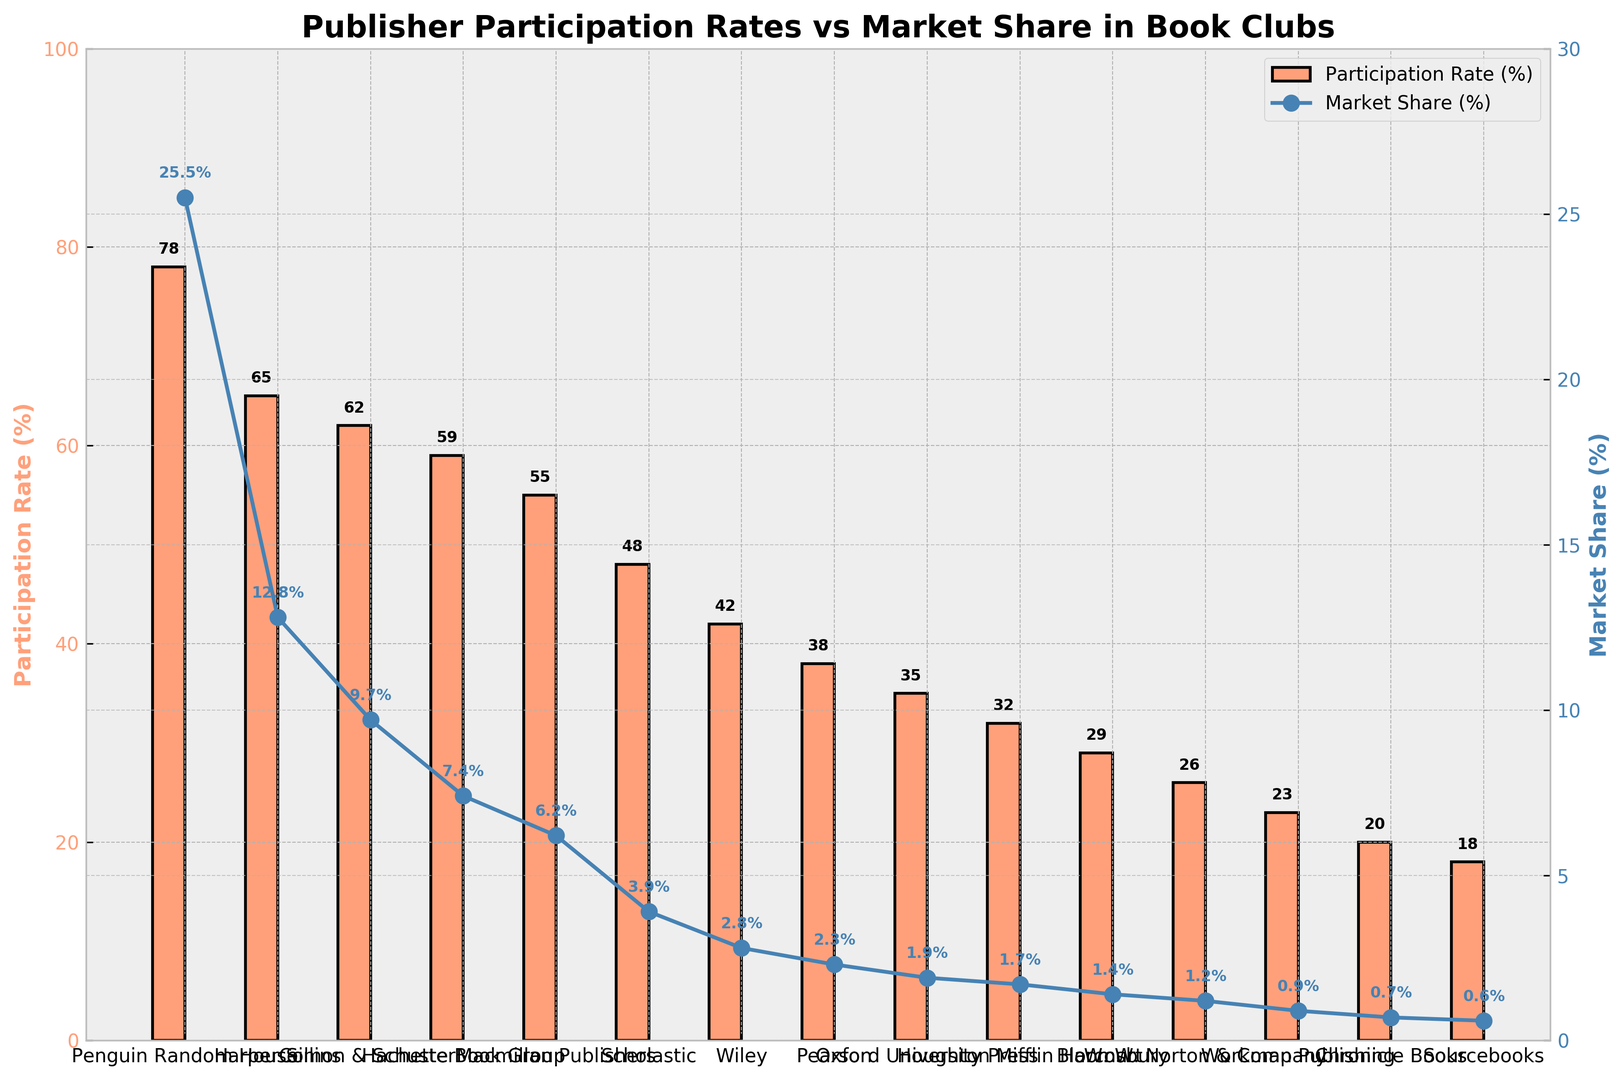What's the participation rate of HarperCollins? To find the participation rate of HarperCollins, look at the height of the corresponding red bar on the chart labelled HarperCollins, which shows participation rates on the y-axis.
Answer: 65% How does Pearson's participation rate compare to Oxford University Press's participation rate? Find the red bars for Pearson and Oxford University Press. Measure the heights of each bar to see the participation rates, which are 38% for Pearson and 35% for Oxford University Press. Comparing these, Pearson's participation rate is higher by 3%.
Answer: Pearson's participation rate is 3% higher than Oxford University Press's Which publisher has the largest market share, and what is it? The largest market share is represented by the highest blue dot on the second y-axis. Identifying the highest blue dot, it belongs to Penguin Random House with a market share of 25.5%.
Answer: Penguin Random House, 25.5% What's the total participation rate of Penguin Random House and HarperCollins combined? The participation rate of Penguin Random House is 78%, and HarperCollins is 65%. Add these two values together to get the combined total. So, 78% + 65% = 143%.
Answer: 143% Is there any publisher for which the participation rate exceeds 50% but the market share is below 10%? Identify publishers with participation rates above 50% and below 10% market share. HarperCollins has a participation rate of 65% with a market share of 12.8%, so it's not a match. Simon & Schuster's participation rate is 62% with a market share of 9.7%, meeting the criteria.
Answer: Simon & Schuster What visual feature indicates the participation rate, and how is it different for market share? The red bars indicate the participation rate, while the blue dots connected by lines illustrate the market share. The red bars' height corresponds to the participation rates on the left y-axis, while the position of blue dots along the right y-axis represents market share values.
Answer: Red bars for participation rate, blue dots for market share Which publisher has the highest participation rate and what visual clue indicates this on the chart? The highest red bar on the chart represents the highest participation rate. This bar belongs to Penguin Random House, which has a participation rate of 78%.
Answer: Penguin Random House, highest red bar How many publishers have a market share of less than 5%? Count the number of blue dots positioned below the 5% mark on the right y-axis. These publishers are Scholastic, Wiley, Pearson, Oxford University Press, Houghton Mifflin Harcourt, Bloomsbury, W. W. Norton & Company, Workman Publishing, Chronicle Books, and Sourcebooks.
Answer: 10 